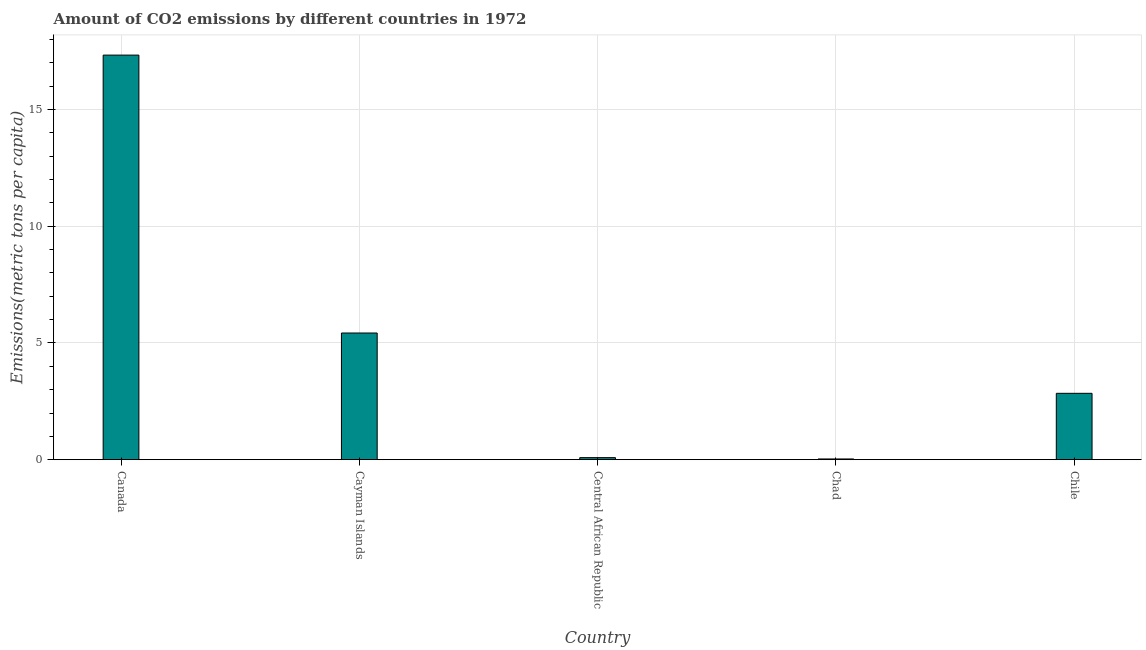Does the graph contain any zero values?
Your response must be concise. No. What is the title of the graph?
Offer a very short reply. Amount of CO2 emissions by different countries in 1972. What is the label or title of the Y-axis?
Your answer should be very brief. Emissions(metric tons per capita). What is the amount of co2 emissions in Cayman Islands?
Ensure brevity in your answer.  5.43. Across all countries, what is the maximum amount of co2 emissions?
Provide a short and direct response. 17.33. Across all countries, what is the minimum amount of co2 emissions?
Offer a very short reply. 0.03. In which country was the amount of co2 emissions minimum?
Your answer should be very brief. Chad. What is the sum of the amount of co2 emissions?
Provide a short and direct response. 25.72. What is the difference between the amount of co2 emissions in Cayman Islands and Central African Republic?
Your answer should be very brief. 5.34. What is the average amount of co2 emissions per country?
Offer a terse response. 5.14. What is the median amount of co2 emissions?
Make the answer very short. 2.84. In how many countries, is the amount of co2 emissions greater than 12 metric tons per capita?
Your answer should be very brief. 1. What is the ratio of the amount of co2 emissions in Chad to that in Chile?
Make the answer very short. 0.01. Is the amount of co2 emissions in Canada less than that in Central African Republic?
Give a very brief answer. No. What is the difference between the highest and the second highest amount of co2 emissions?
Your response must be concise. 11.9. Is the sum of the amount of co2 emissions in Central African Republic and Chile greater than the maximum amount of co2 emissions across all countries?
Provide a short and direct response. No. In how many countries, is the amount of co2 emissions greater than the average amount of co2 emissions taken over all countries?
Keep it short and to the point. 2. What is the Emissions(metric tons per capita) in Canada?
Give a very brief answer. 17.33. What is the Emissions(metric tons per capita) in Cayman Islands?
Make the answer very short. 5.43. What is the Emissions(metric tons per capita) in Central African Republic?
Provide a short and direct response. 0.09. What is the Emissions(metric tons per capita) of Chad?
Provide a short and direct response. 0.03. What is the Emissions(metric tons per capita) in Chile?
Provide a succinct answer. 2.84. What is the difference between the Emissions(metric tons per capita) in Canada and Cayman Islands?
Provide a succinct answer. 11.9. What is the difference between the Emissions(metric tons per capita) in Canada and Central African Republic?
Keep it short and to the point. 17.24. What is the difference between the Emissions(metric tons per capita) in Canada and Chad?
Provide a succinct answer. 17.3. What is the difference between the Emissions(metric tons per capita) in Canada and Chile?
Your answer should be compact. 14.49. What is the difference between the Emissions(metric tons per capita) in Cayman Islands and Central African Republic?
Ensure brevity in your answer.  5.34. What is the difference between the Emissions(metric tons per capita) in Cayman Islands and Chad?
Keep it short and to the point. 5.39. What is the difference between the Emissions(metric tons per capita) in Cayman Islands and Chile?
Make the answer very short. 2.58. What is the difference between the Emissions(metric tons per capita) in Central African Republic and Chad?
Your response must be concise. 0.06. What is the difference between the Emissions(metric tons per capita) in Central African Republic and Chile?
Your response must be concise. -2.75. What is the difference between the Emissions(metric tons per capita) in Chad and Chile?
Ensure brevity in your answer.  -2.81. What is the ratio of the Emissions(metric tons per capita) in Canada to that in Cayman Islands?
Keep it short and to the point. 3.19. What is the ratio of the Emissions(metric tons per capita) in Canada to that in Central African Republic?
Give a very brief answer. 195.27. What is the ratio of the Emissions(metric tons per capita) in Canada to that in Chad?
Your answer should be compact. 546.51. What is the ratio of the Emissions(metric tons per capita) in Canada to that in Chile?
Your answer should be very brief. 6.1. What is the ratio of the Emissions(metric tons per capita) in Cayman Islands to that in Central African Republic?
Keep it short and to the point. 61.14. What is the ratio of the Emissions(metric tons per capita) in Cayman Islands to that in Chad?
Provide a succinct answer. 171.12. What is the ratio of the Emissions(metric tons per capita) in Cayman Islands to that in Chile?
Offer a terse response. 1.91. What is the ratio of the Emissions(metric tons per capita) in Central African Republic to that in Chad?
Provide a succinct answer. 2.8. What is the ratio of the Emissions(metric tons per capita) in Central African Republic to that in Chile?
Make the answer very short. 0.03. What is the ratio of the Emissions(metric tons per capita) in Chad to that in Chile?
Offer a very short reply. 0.01. 